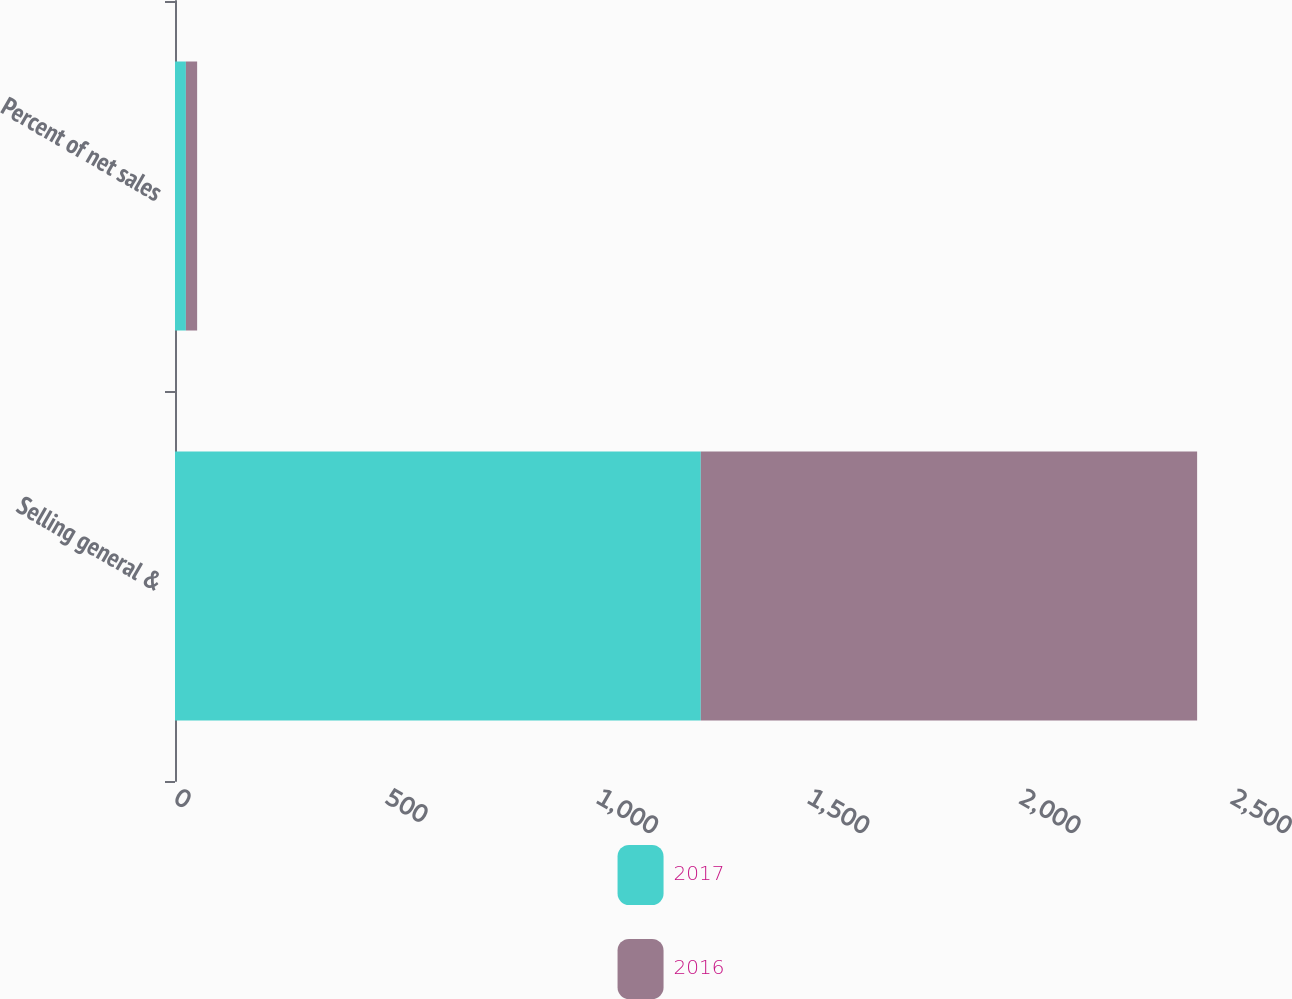Convert chart. <chart><loc_0><loc_0><loc_500><loc_500><stacked_bar_chart><ecel><fcel>Selling general &<fcel>Percent of net sales<nl><fcel>2017<fcel>1244.8<fcel>25.8<nl><fcel>2016<fcel>1175<fcel>26.6<nl></chart> 